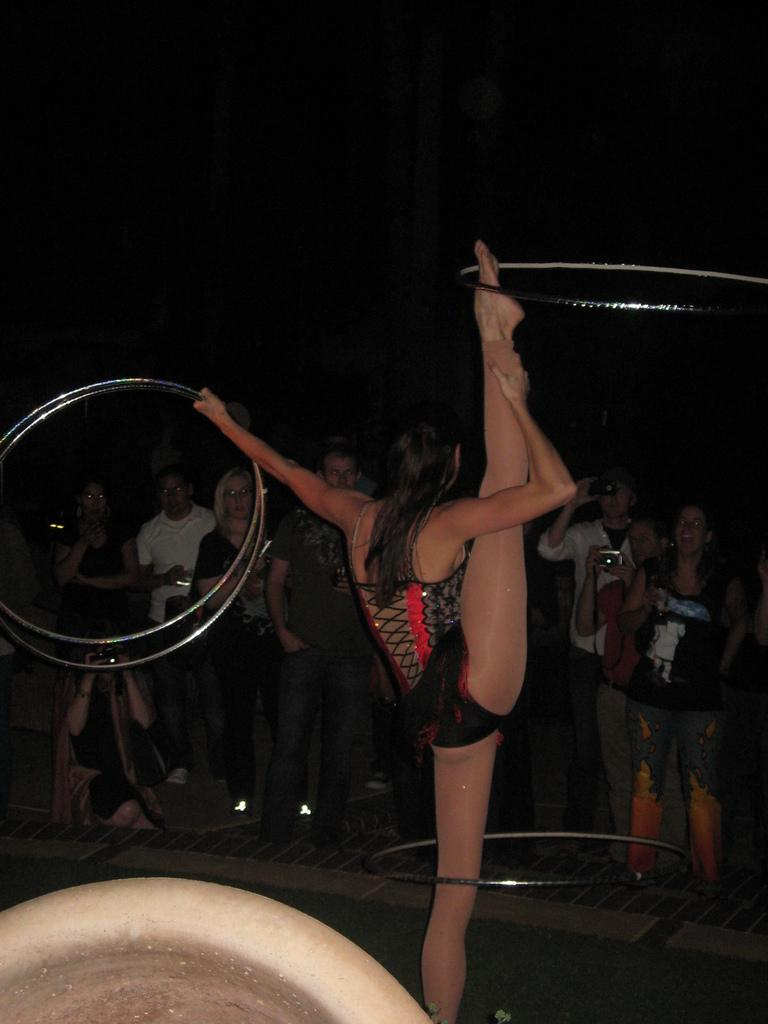Who is the main subject in the image? There is a woman in the middle of the image. What is the woman doing in the image? The woman is standing and holding rings. Are there any other people in the image? Yes, there are people behind the woman. What are the people doing in the image? The people are holding cameras and watching the woman. How many kittens are playing with the rings in the image? There are no kittens present in the image. What is the son of the woman doing in the image? There is no mention of a son in the image or the provided facts. 